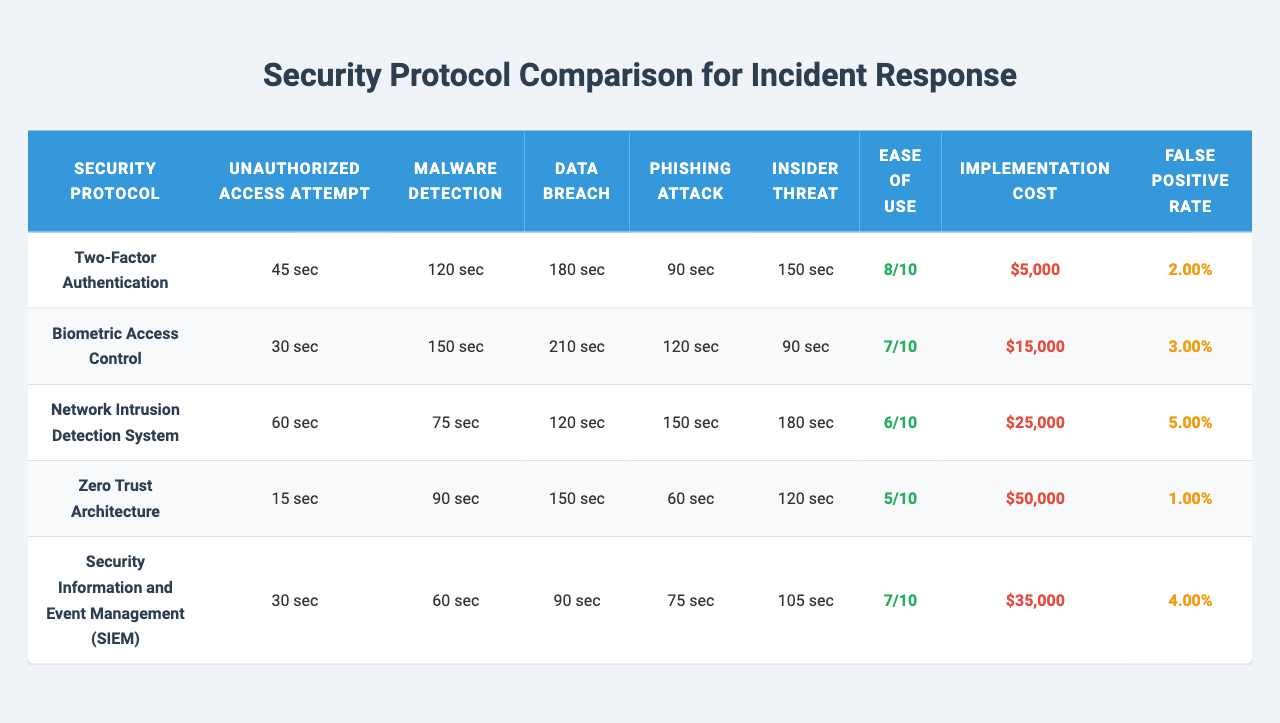What's the incident response time for Malware Detection using Two-Factor Authentication? By checking the table under the column for "Malware Detection" and row for "Two-Factor Authentication," we see the response time is 120 seconds.
Answer: 120 seconds Which security protocol has the quickest response time for Unauthorized Access Attempt? Looking at the “Unauthorized Access Attempt” column, the quickest response time corresponds to "Zero Trust Architecture" with a time of 15 seconds.
Answer: 15 seconds What is the average incident response time for Data Breach across all protocols? Summing all incident response times for Data Breach: (180 + 210 + 120 + 150 + 90) = 750 seconds; dividing by the 5 protocols gives us 750/5 = 150 seconds.
Answer: 150 seconds Is the ease of use score for Network Intrusion Detection System higher than 6? The score for Network Intrusion Detection System is 6, thus it is not higher than 6.
Answer: No Which security protocol has the highest implementation cost? By examining the implementation costs, "Zero Trust Architecture" has the highest cost of $50,000.
Answer: $50,000 How does the false positive rate for Biometric Access Control compare to that of Zero Trust Architecture? The false positive rate for Biometric Access Control is 0.03, while for Zero Trust Architecture it's 0.01. Since 0.03 is greater than 0.01, Biometric Access Control has a higher rate.
Answer: Higher What is the total incident response time for Phishing Attack across all protocols? Adding the incident response times for Phishing Attack gives us: (90 + 120 + 150 + 60 + 75) = 495 seconds, which is the total response time across all protocols.
Answer: 495 seconds Is there a security protocol that has both a higher ease of use score and lower response time for Insider Threat than Security Information and Event Management (SIEM)? SIEM's ease of use score is 7 and its response time for Insider Threat is 105 seconds. "Zero Trust Architecture" has an ease of use score of 5 and a response time of 120 seconds (not lower). Biometric Access Control has an ease of use score of 7 but a response time of 90 seconds (which is lower). Hence, yes, there is one.
Answer: Yes Which protocol has the highest false positive rate and how does it compare to the lowest? The highest false positive rate is for Network Intrusion Detection System at 0.05 while the lowest is for Zero Trust Architecture at 0.01. The difference is 0.05 - 0.01 = 0.04.
Answer: 0.04 What is the reaction time for Malware Detection using the protocol with the least ease of use? The protocol with the least ease of use is "Zero Trust Architecture" with a score of 5. Its response time for Malware Detection is 90 seconds.
Answer: 90 seconds If Two-Factor Authentication improves its response time for Data Breach to 150 seconds, how many protocols will have an equal response time? Currently, "Security Information and Event Management (SIEM)" also has a Data Breach response time of 90 seconds, and if Two-Factor Authentication's response time is improved to 150 seconds, "Zero Trust Architecture" will also then match it. Thus, there will be 2 protocols with the equal response time.
Answer: 2 